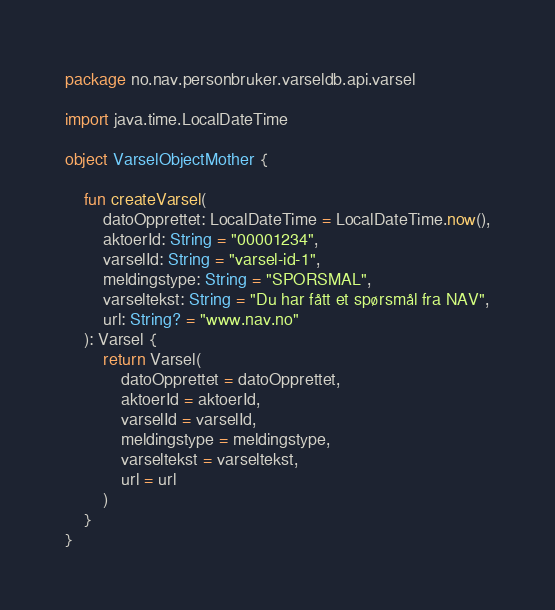<code> <loc_0><loc_0><loc_500><loc_500><_Kotlin_>package no.nav.personbruker.varseldb.api.varsel

import java.time.LocalDateTime

object VarselObjectMother {

    fun createVarsel(
        datoOpprettet: LocalDateTime = LocalDateTime.now(),
        aktoerId: String = "00001234",
        varselId: String = "varsel-id-1",
        meldingstype: String = "SPORSMAL",
        varseltekst: String = "Du har fått et spørsmål fra NAV",
        url: String? = "www.nav.no"
    ): Varsel {
        return Varsel(
            datoOpprettet = datoOpprettet,
            aktoerId = aktoerId,
            varselId = varselId,
            meldingstype = meldingstype,
            varseltekst = varseltekst,
            url = url
        )
    }
}
</code> 